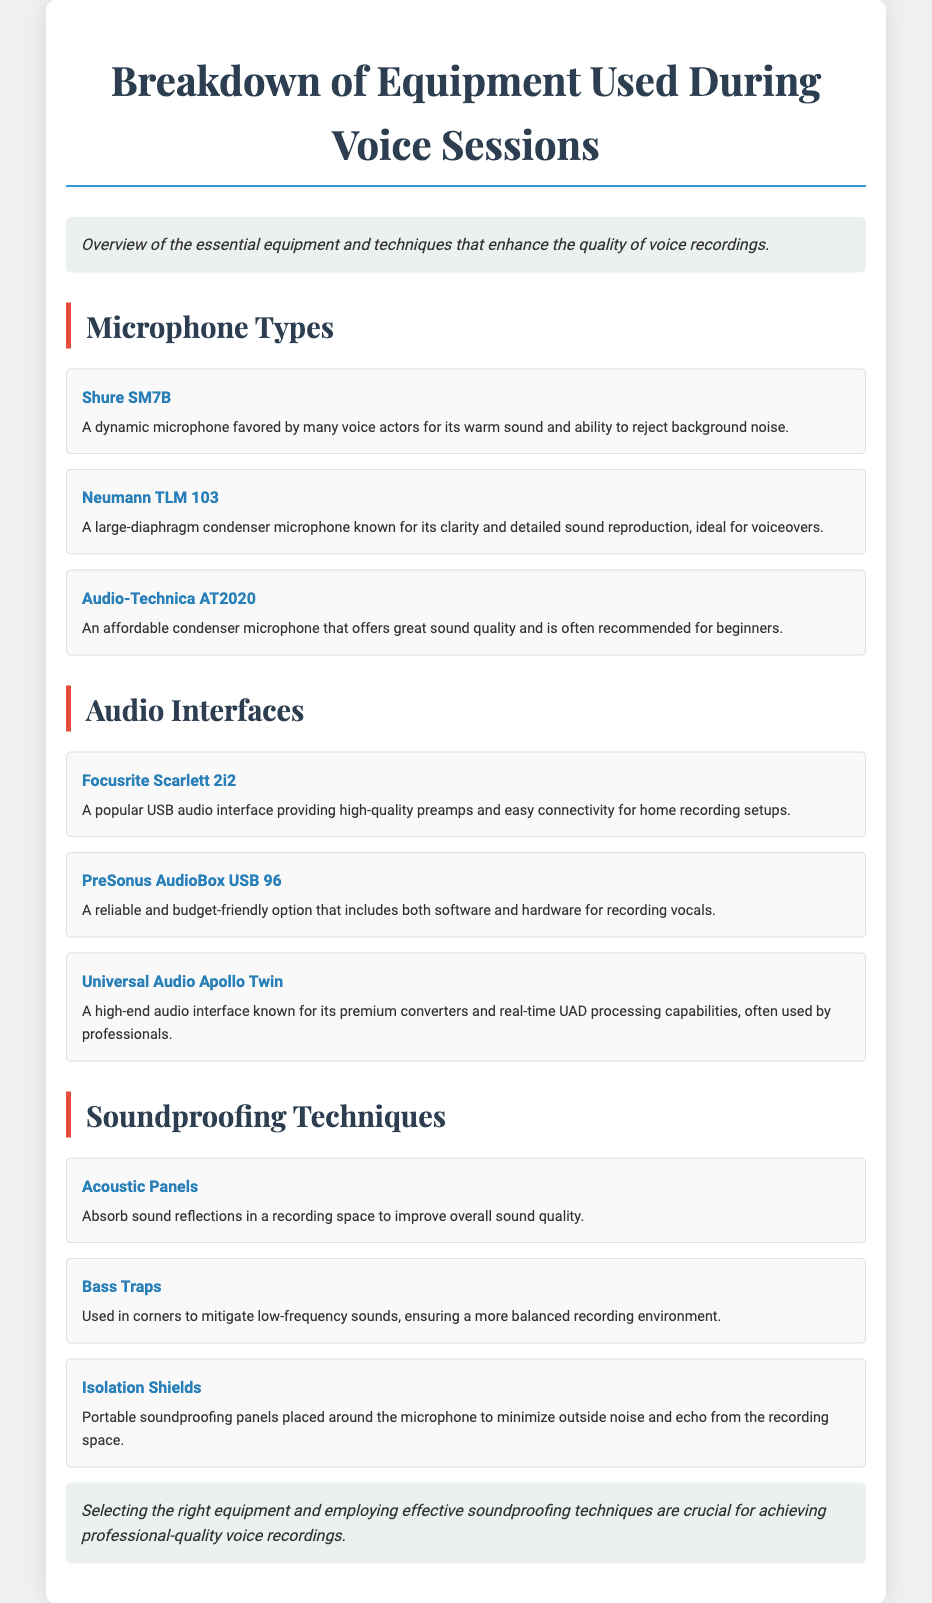what is a popular dynamic microphone used by voice actors? The document lists the Shure SM7B as a popular dynamic microphone favored by many voice actors.
Answer: Shure SM7B which microphone is known for its clarity and detailed sound reproduction? The Neumann TLM 103 is mentioned as a large-diaphragm condenser microphone known for its clarity and detailed sound reproduction.
Answer: Neumann TLM 103 how many audio interfaces are mentioned in the document? There are three audio interfaces listed in the document.
Answer: 3 what is the purpose of acoustic panels? Acoustic panels are described as items that absorb sound reflections in a recording space to improve overall sound quality.
Answer: Improve sound quality which audio interface is known for its premium converters and real-time processing capabilities? The Universal Audio Apollo Twin is highlighted as a high-end audio interface known for its premium converters and real-time UAD processing capabilities.
Answer: Universal Audio Apollo Twin what technique is used in corners to mitigate low-frequency sounds? The document specifies that bass traps are used in corners to mitigate low-frequency sounds.
Answer: Bass traps what are isolation shields used for? Isolation shields are mentioned as portable soundproofing panels placed around the microphone to minimize outside noise and echo.
Answer: Minimize outside noise which two types of microphones are recommended for beginners? The document states that the Audio-Technica AT2020 is often recommended for beginners.
Answer: Audio-Technica AT2020 what is the main focus of the document? The document provides an overview of essential equipment and techniques that enhance the quality of voice recordings.
Answer: Overview of essential equipment and techniques 